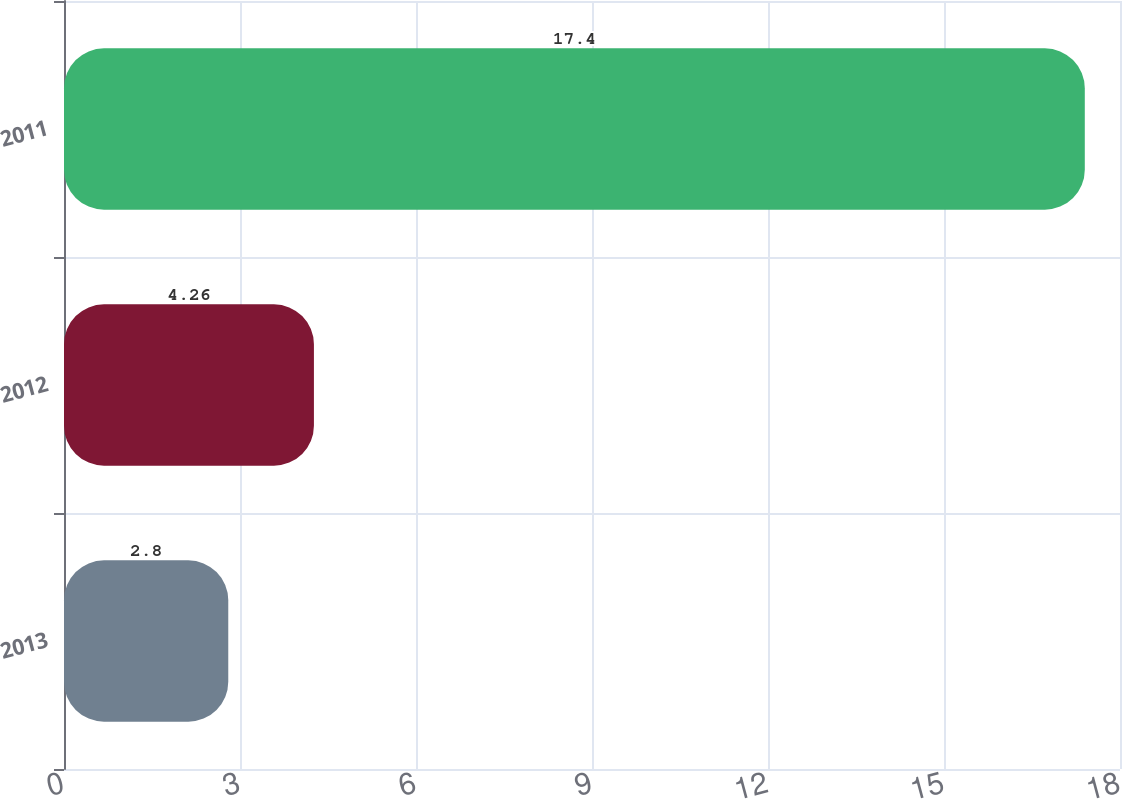Convert chart to OTSL. <chart><loc_0><loc_0><loc_500><loc_500><bar_chart><fcel>2013<fcel>2012<fcel>2011<nl><fcel>2.8<fcel>4.26<fcel>17.4<nl></chart> 